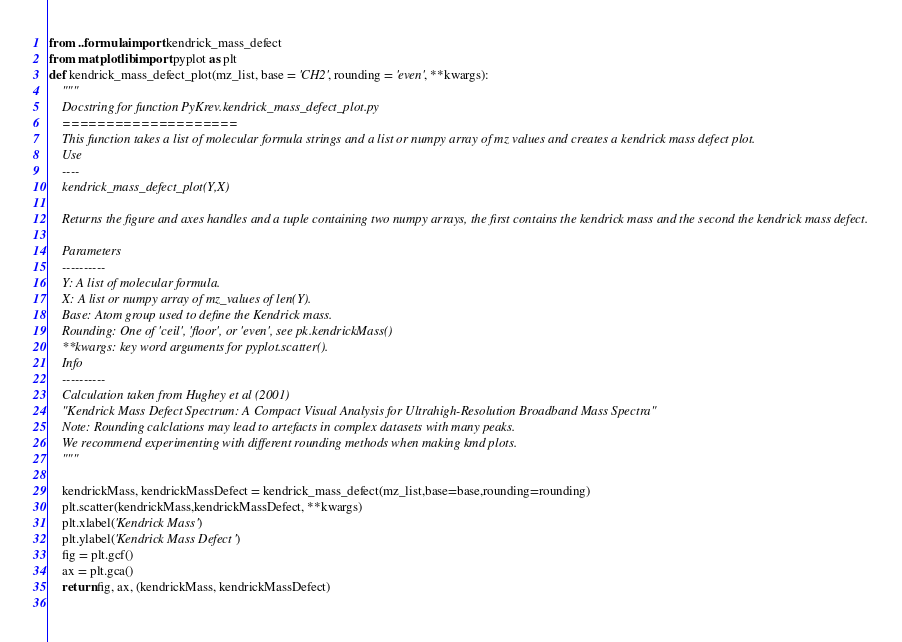<code> <loc_0><loc_0><loc_500><loc_500><_Python_>from ..formula import kendrick_mass_defect
from matplotlib import pyplot as plt
def kendrick_mass_defect_plot(mz_list, base = 'CH2', rounding = 'even', **kwargs):
    """ 
	Docstring for function PyKrev.kendrick_mass_defect_plot.py
	====================
	This function takes a list of molecular formula strings and a list or numpy array of mz values and creates a kendrick mass defect plot.
	Use
	----
	kendrick_mass_defect_plot(Y,X)
    
	Returns the figure and axes handles and a tuple containing two numpy arrays, the first contains the kendrick mass and the second the kendrick mass defect. 
    
	Parameters
	----------
	Y: A list of molecular formula. 
    X: A list or numpy array of mz_values of len(Y). 
	Base: Atom group used to define the Kendrick mass.
    Rounding: One of 'ceil', 'floor', or 'even', see pk.kendrickMass()
    **kwargs: key word arguments for pyplot.scatter(). 
    Info
	----------
    Calculation taken from Hughey et al (2001) 
    "Kendrick Mass Defect Spectrum: A Compact Visual Analysis for Ultrahigh-Resolution Broadband Mass Spectra"
    Note: Rounding calclations may lead to artefacts in complex datasets with many peaks. 
    We recommend experimenting with different rounding methods when making kmd plots.
    """
    
    kendrickMass, kendrickMassDefect = kendrick_mass_defect(mz_list,base=base,rounding=rounding)
    plt.scatter(kendrickMass,kendrickMassDefect, **kwargs)
    plt.xlabel('Kendrick Mass')
    plt.ylabel('Kendrick Mass Defect')
    fig = plt.gcf()
    ax = plt.gca()
    return fig, ax, (kendrickMass, kendrickMassDefect)
    </code> 